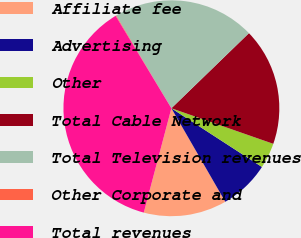<chart> <loc_0><loc_0><loc_500><loc_500><pie_chart><fcel>Affiliate fee<fcel>Advertising<fcel>Other<fcel>Total Cable Network<fcel>Total Television revenues<fcel>Other Corporate and<fcel>Total revenues<nl><fcel>12.44%<fcel>7.52%<fcel>3.81%<fcel>17.59%<fcel>21.31%<fcel>0.09%<fcel>37.24%<nl></chart> 